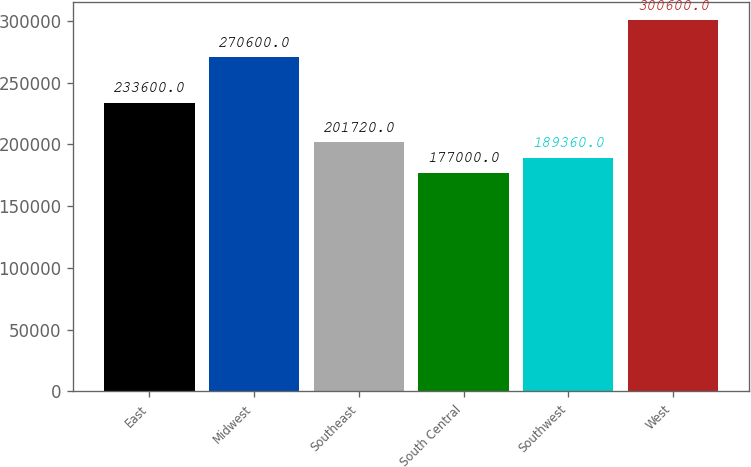Convert chart to OTSL. <chart><loc_0><loc_0><loc_500><loc_500><bar_chart><fcel>East<fcel>Midwest<fcel>Southeast<fcel>South Central<fcel>Southwest<fcel>West<nl><fcel>233600<fcel>270600<fcel>201720<fcel>177000<fcel>189360<fcel>300600<nl></chart> 